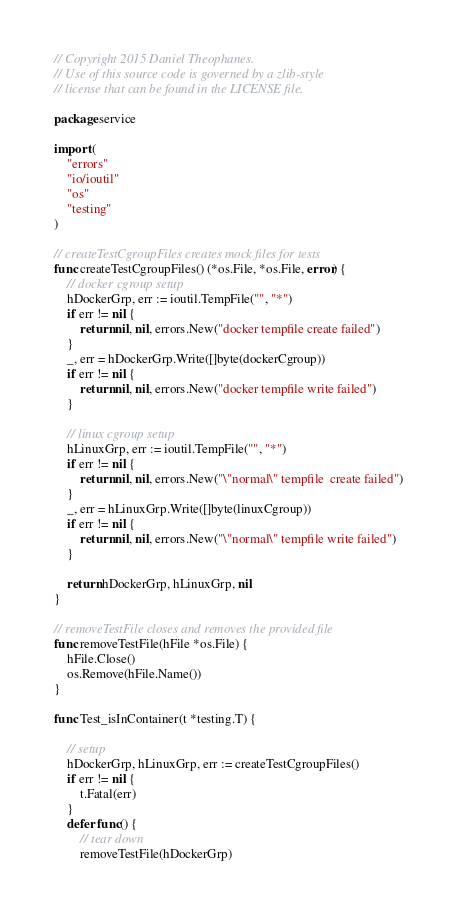Convert code to text. <code><loc_0><loc_0><loc_500><loc_500><_Go_>// Copyright 2015 Daniel Theophanes.
// Use of this source code is governed by a zlib-style
// license that can be found in the LICENSE file.

package service

import (
	"errors"
	"io/ioutil"
	"os"
	"testing"
)

// createTestCgroupFiles creates mock files for tests
func createTestCgroupFiles() (*os.File, *os.File, error) {
	// docker cgroup setup
	hDockerGrp, err := ioutil.TempFile("", "*")
	if err != nil {
		return nil, nil, errors.New("docker tempfile create failed")
	}
	_, err = hDockerGrp.Write([]byte(dockerCgroup))
	if err != nil {
		return nil, nil, errors.New("docker tempfile write failed")
	}

	// linux cgroup setup
	hLinuxGrp, err := ioutil.TempFile("", "*")
	if err != nil {
		return nil, nil, errors.New("\"normal\" tempfile  create failed")
	}
	_, err = hLinuxGrp.Write([]byte(linuxCgroup))
	if err != nil {
		return nil, nil, errors.New("\"normal\" tempfile write failed")
	}

	return hDockerGrp, hLinuxGrp, nil
}

// removeTestFile closes and removes the provided file
func removeTestFile(hFile *os.File) {
	hFile.Close()
	os.Remove(hFile.Name())
}

func Test_isInContainer(t *testing.T) {

	// setup
	hDockerGrp, hLinuxGrp, err := createTestCgroupFiles()
	if err != nil {
		t.Fatal(err)
	}
	defer func() {
		// tear down
		removeTestFile(hDockerGrp)</code> 